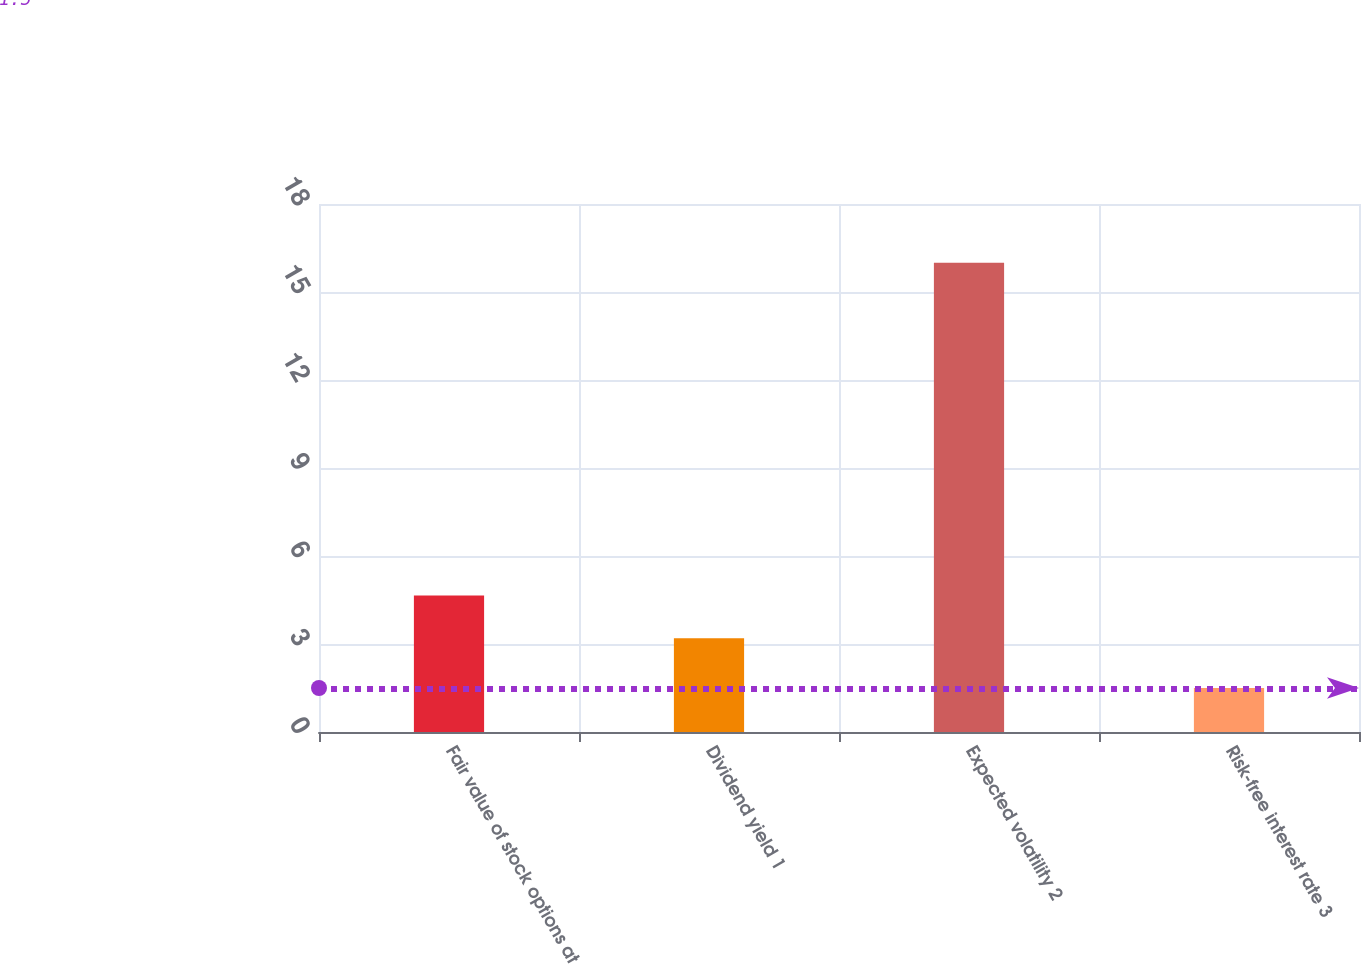<chart> <loc_0><loc_0><loc_500><loc_500><bar_chart><fcel>Fair value of stock options at<fcel>Dividend yield 1<fcel>Expected volatility 2<fcel>Risk-free interest rate 3<nl><fcel>4.65<fcel>3.2<fcel>16<fcel>1.5<nl></chart> 